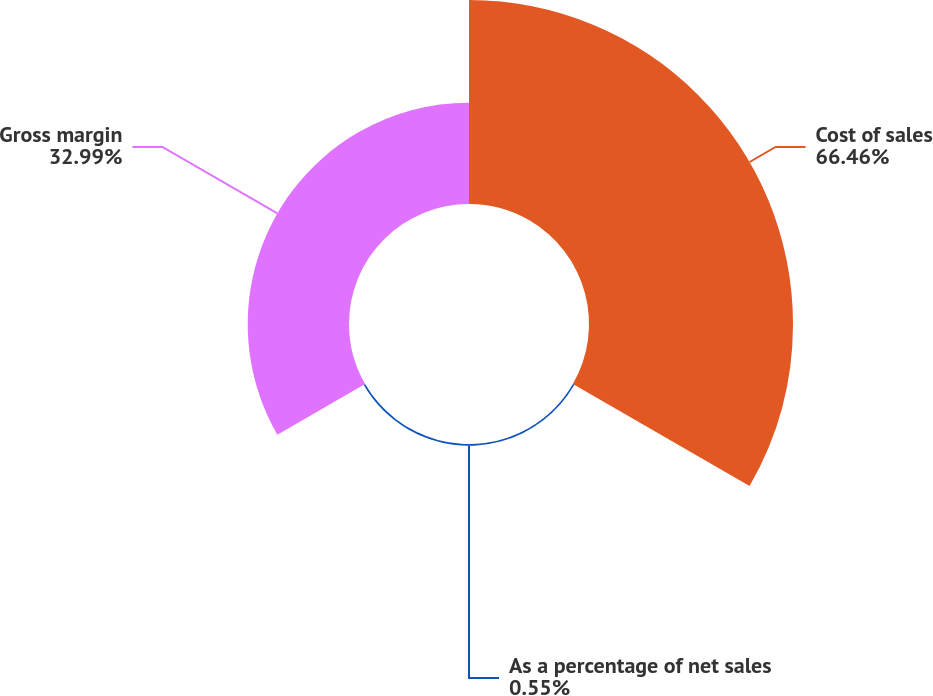Convert chart to OTSL. <chart><loc_0><loc_0><loc_500><loc_500><pie_chart><fcel>Cost of sales<fcel>As a percentage of net sales<fcel>Gross margin<nl><fcel>66.45%<fcel>0.55%<fcel>32.99%<nl></chart> 